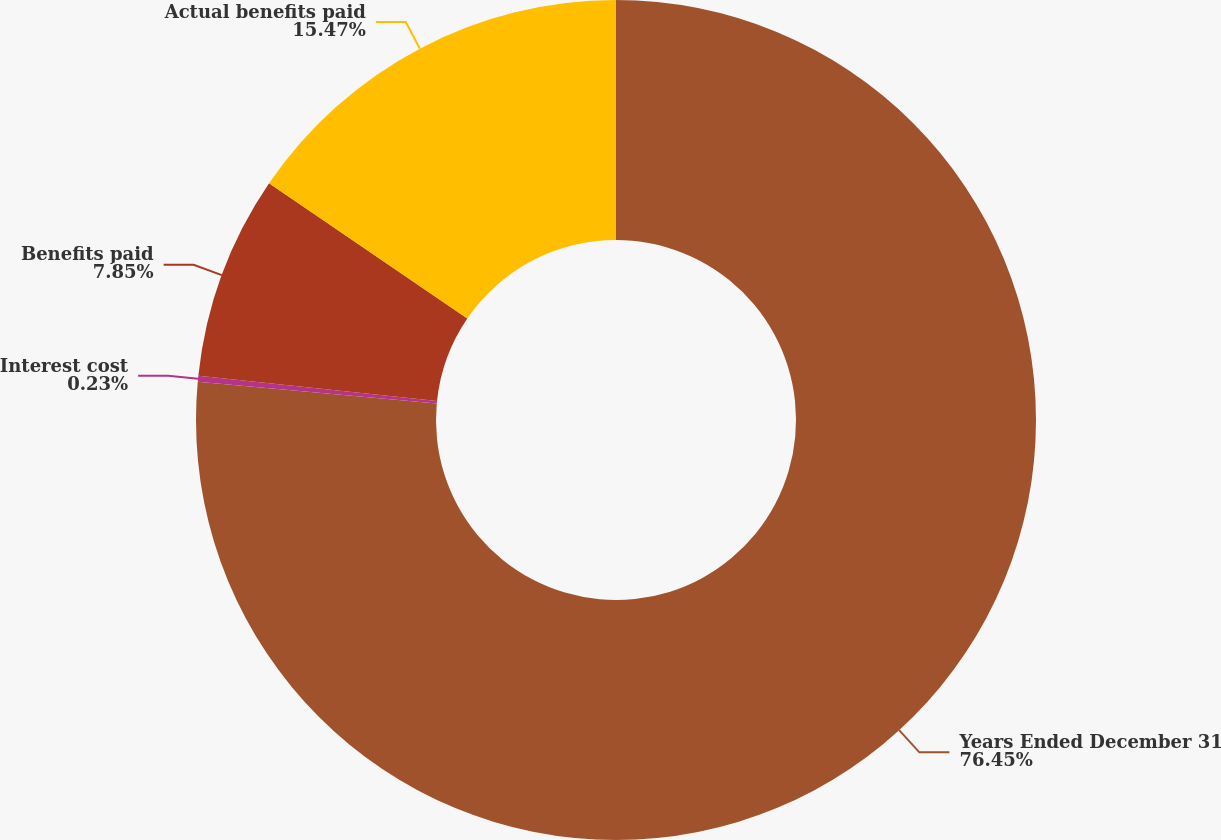Convert chart. <chart><loc_0><loc_0><loc_500><loc_500><pie_chart><fcel>Years Ended December 31<fcel>Interest cost<fcel>Benefits paid<fcel>Actual benefits paid<nl><fcel>76.45%<fcel>0.23%<fcel>7.85%<fcel>15.47%<nl></chart> 